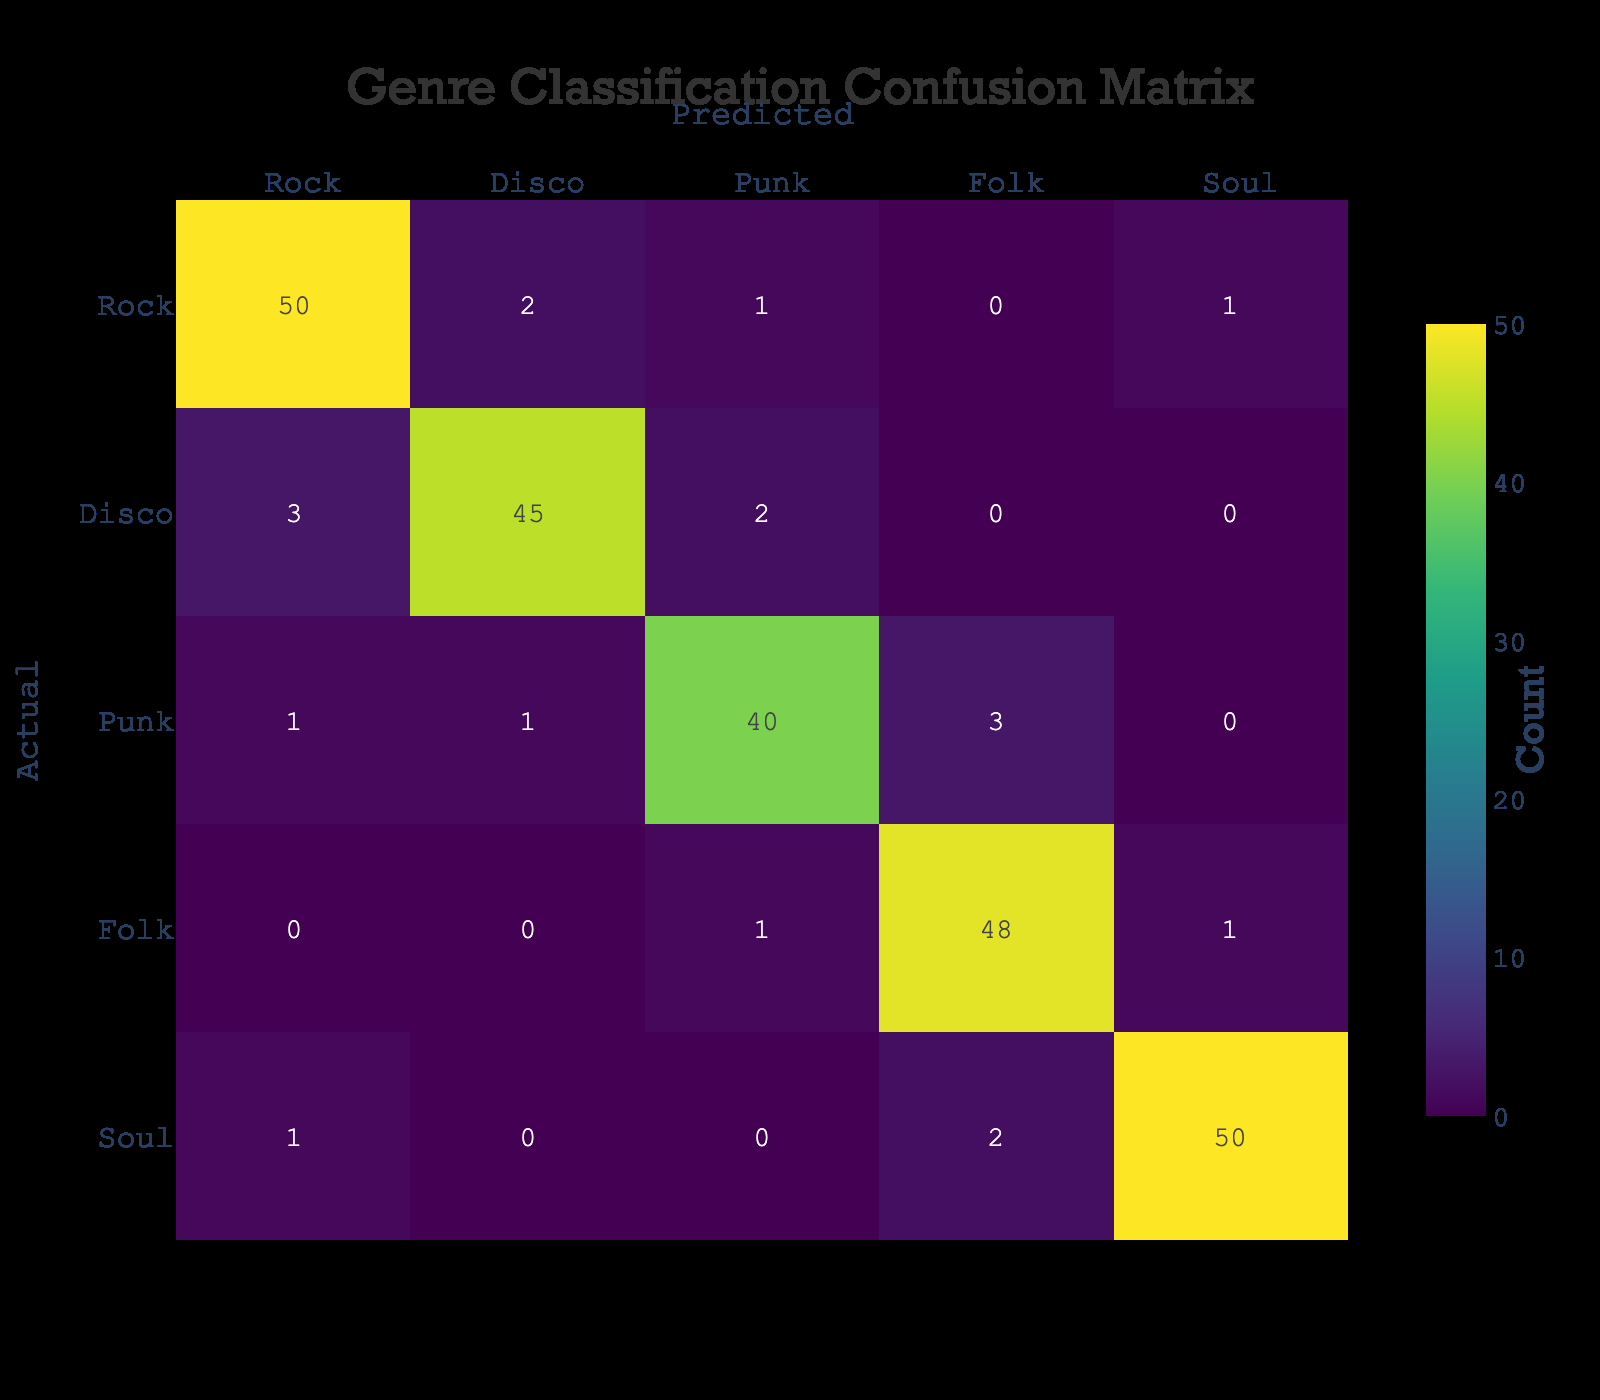What is the number of correctly classified Rock tracks? To find the correctly classified Rock tracks, we refer to the cell in the 'Rock' row and 'Rock' column, which shows the count of 50.
Answer: 50 How many tracks were incorrectly classified as Punk instead of Disco? For Disco, the tracks that were incorrectly classified as Punk, we look at the 'Disco' row and the 'Punk' column, which is 2.
Answer: 2 What is the total number of Folk tracks that were predicted as anything other than Folk? We gather data from the Folk row, excluding the correctly classified count (48). The incorrectly classified ones are found in Punk (1) and Soul (1), giving a total of 2.
Answer: 2 Is the number of Songs predicted as Soul greater than the number predicted as Disco? Analyzing the predicted counts, Soul has 50, whereas Disco has 45. Since 50 is greater than 45, the statement is true.
Answer: Yes How many total tracks were classified as Punk? By summing the entire Punk row (1 + 1 + 40 + 3 + 0), the total count is 45 tracks classified as Punk.
Answer: 45 What percentage of actual Disco tracks were correctly classified? The correctly classified Disco tracks come from the cell in the 'Disco' row and 'Disco' column, which is 45. The total Disco tracks were 50 (3 + 45 + 2), so the percentage is (45/50) * 100 = 90%.
Answer: 90% Which genre had the least number of incorrectly classified tracks? Investigating each row for incorrectly classified tracks, Folk had 2 (1 as Punk, 1 as Soul), while other genres had more. Therefore, Folk had the least.
Answer: Folk How many Soul tracks were predicted as Folk? We look at the 'Soul' row and the 'Folk' column, which indicates that 2 Soul tracks were predicted as Folk.
Answer: 2 What is the difference between the correctly classified Disco tracks and the correctly classified Folk tracks? The correctly classified Disco tracks are 45, and for Folk, it is 48. The difference is 48 - 45 = 3.
Answer: 3 